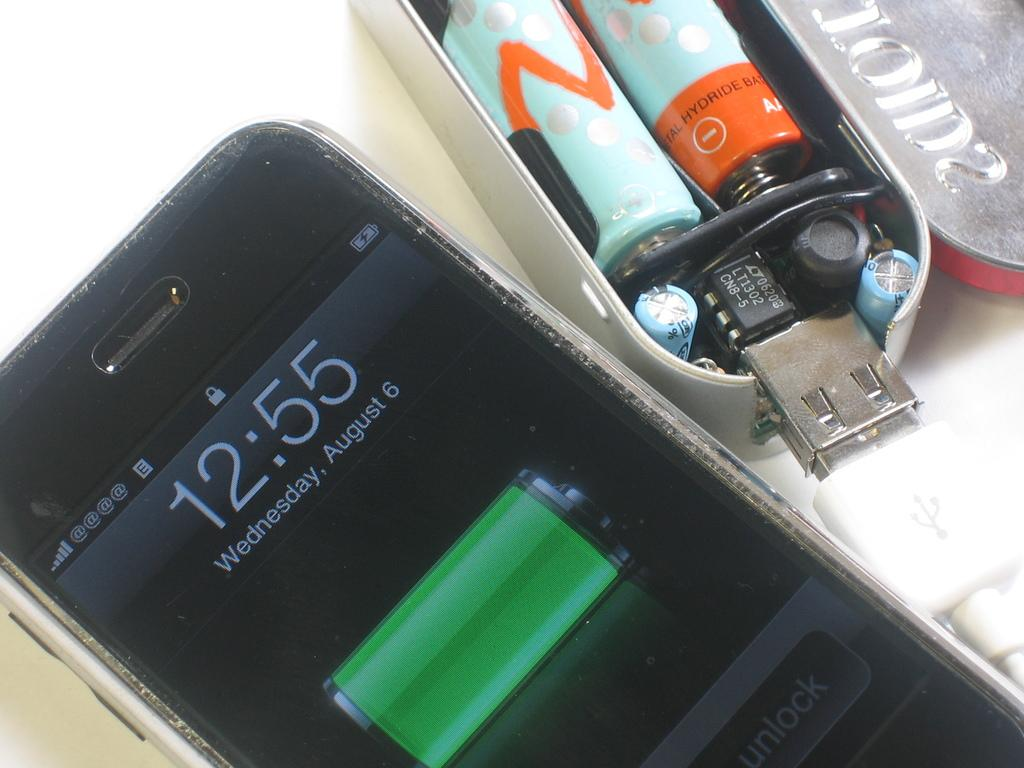<image>
Create a compact narrative representing the image presented. The phone screen displays a time of 12:55. 